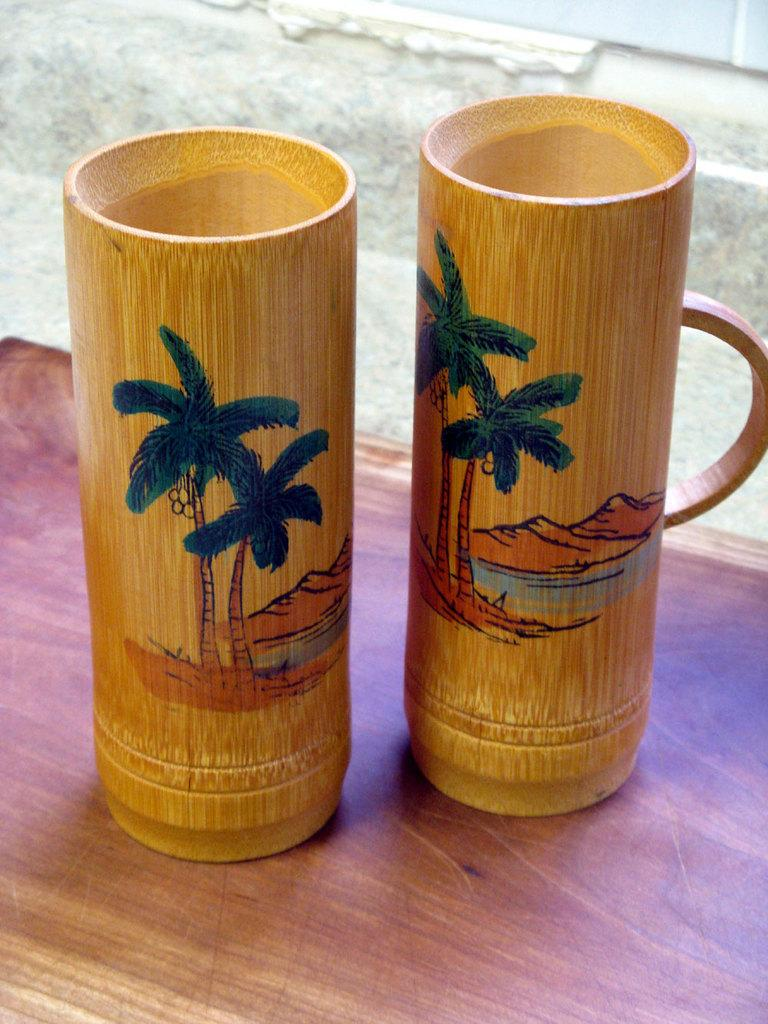What type of glasses are in the cup in the image? The glasses in the cup are wooden glasses. Where are the wooden glasses located in the image? The wooden glasses are placed on a table. How many jellyfish can be seen swimming in the cup of wooden glasses in the image? There are no jellyfish present in the image; it features a cup of wooden glasses placed on a table. 